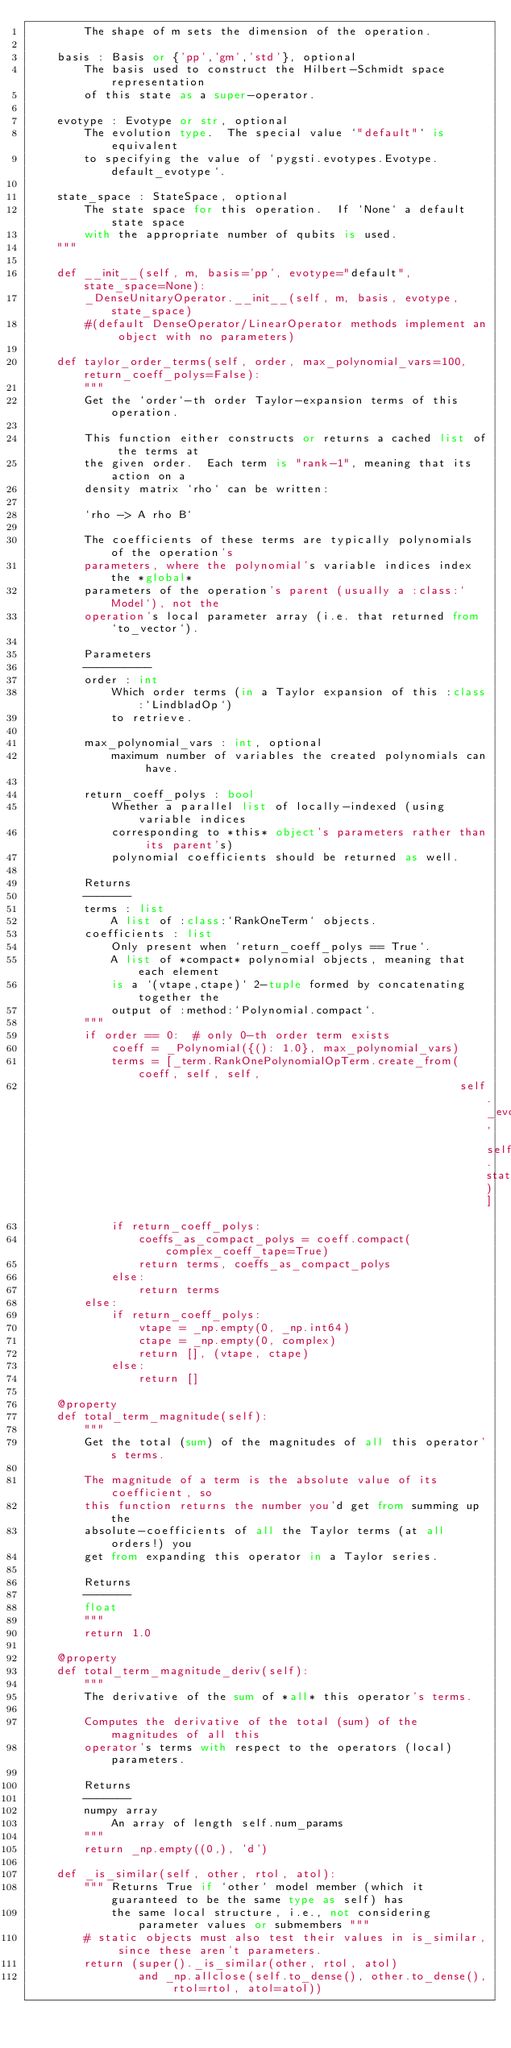Convert code to text. <code><loc_0><loc_0><loc_500><loc_500><_Python_>        The shape of m sets the dimension of the operation.

    basis : Basis or {'pp','gm','std'}, optional
        The basis used to construct the Hilbert-Schmidt space representation
        of this state as a super-operator.

    evotype : Evotype or str, optional
        The evolution type.  The special value `"default"` is equivalent
        to specifying the value of `pygsti.evotypes.Evotype.default_evotype`.

    state_space : StateSpace, optional
        The state space for this operation.  If `None` a default state space
        with the appropriate number of qubits is used.
    """

    def __init__(self, m, basis='pp', evotype="default", state_space=None):
        _DenseUnitaryOperator.__init__(self, m, basis, evotype, state_space)
        #(default DenseOperator/LinearOperator methods implement an object with no parameters)

    def taylor_order_terms(self, order, max_polynomial_vars=100, return_coeff_polys=False):
        """
        Get the `order`-th order Taylor-expansion terms of this operation.

        This function either constructs or returns a cached list of the terms at
        the given order.  Each term is "rank-1", meaning that its action on a
        density matrix `rho` can be written:

        `rho -> A rho B`

        The coefficients of these terms are typically polynomials of the operation's
        parameters, where the polynomial's variable indices index the *global*
        parameters of the operation's parent (usually a :class:`Model`), not the
        operation's local parameter array (i.e. that returned from `to_vector`).

        Parameters
        ----------
        order : int
            Which order terms (in a Taylor expansion of this :class:`LindbladOp`)
            to retrieve.

        max_polynomial_vars : int, optional
            maximum number of variables the created polynomials can have.

        return_coeff_polys : bool
            Whether a parallel list of locally-indexed (using variable indices
            corresponding to *this* object's parameters rather than its parent's)
            polynomial coefficients should be returned as well.

        Returns
        -------
        terms : list
            A list of :class:`RankOneTerm` objects.
        coefficients : list
            Only present when `return_coeff_polys == True`.
            A list of *compact* polynomial objects, meaning that each element
            is a `(vtape,ctape)` 2-tuple formed by concatenating together the
            output of :method:`Polynomial.compact`.
        """
        if order == 0:  # only 0-th order term exists
            coeff = _Polynomial({(): 1.0}, max_polynomial_vars)
            terms = [_term.RankOnePolynomialOpTerm.create_from(coeff, self, self,
                                                               self._evotype, self.state_space)]
            if return_coeff_polys:
                coeffs_as_compact_polys = coeff.compact(complex_coeff_tape=True)
                return terms, coeffs_as_compact_polys
            else:
                return terms
        else:
            if return_coeff_polys:
                vtape = _np.empty(0, _np.int64)
                ctape = _np.empty(0, complex)
                return [], (vtape, ctape)
            else:
                return []

    @property
    def total_term_magnitude(self):
        """
        Get the total (sum) of the magnitudes of all this operator's terms.

        The magnitude of a term is the absolute value of its coefficient, so
        this function returns the number you'd get from summing up the
        absolute-coefficients of all the Taylor terms (at all orders!) you
        get from expanding this operator in a Taylor series.

        Returns
        -------
        float
        """
        return 1.0

    @property
    def total_term_magnitude_deriv(self):
        """
        The derivative of the sum of *all* this operator's terms.

        Computes the derivative of the total (sum) of the magnitudes of all this
        operator's terms with respect to the operators (local) parameters.

        Returns
        -------
        numpy array
            An array of length self.num_params
        """
        return _np.empty((0,), 'd')

    def _is_similar(self, other, rtol, atol):
        """ Returns True if `other` model member (which it guaranteed to be the same type as self) has
            the same local structure, i.e., not considering parameter values or submembers """
        # static objects must also test their values in is_similar, since these aren't parameters.
        return (super()._is_similar(other, rtol, atol)
                and _np.allclose(self.to_dense(), other.to_dense(), rtol=rtol, atol=atol))
</code> 